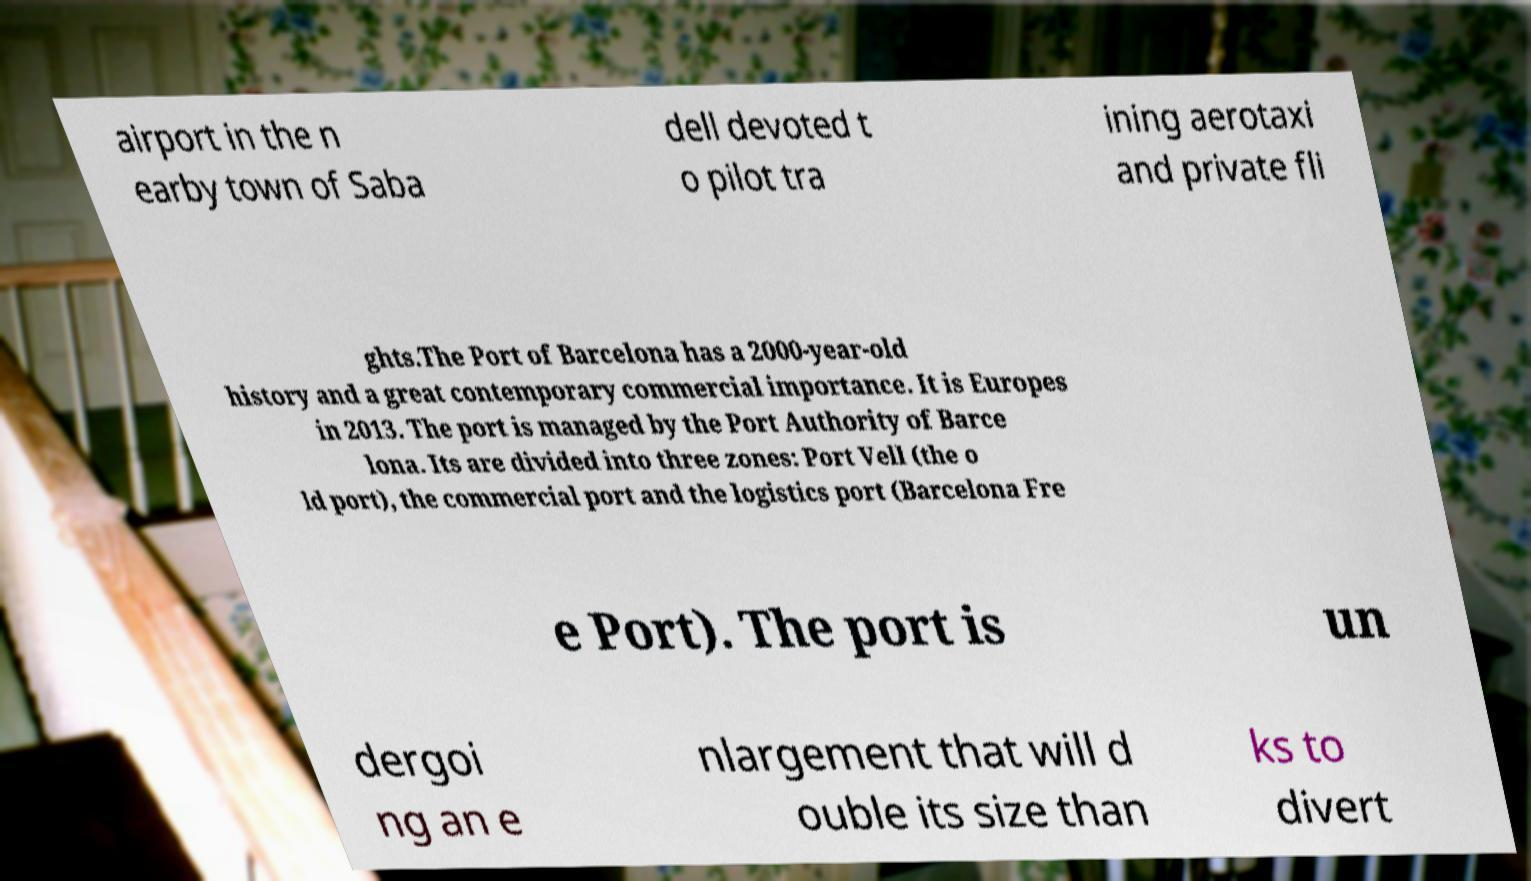Could you assist in decoding the text presented in this image and type it out clearly? airport in the n earby town of Saba dell devoted t o pilot tra ining aerotaxi and private fli ghts.The Port of Barcelona has a 2000-year-old history and a great contemporary commercial importance. It is Europes in 2013. The port is managed by the Port Authority of Barce lona. Its are divided into three zones: Port Vell (the o ld port), the commercial port and the logistics port (Barcelona Fre e Port). The port is un dergoi ng an e nlargement that will d ouble its size than ks to divert 